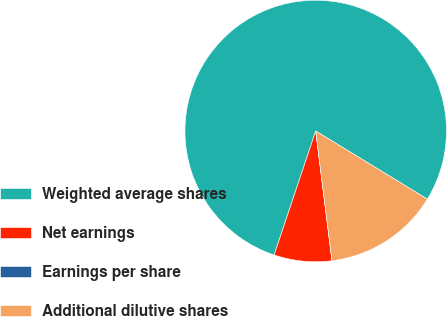<chart> <loc_0><loc_0><loc_500><loc_500><pie_chart><fcel>Weighted average shares<fcel>Net earnings<fcel>Earnings per share<fcel>Additional dilutive shares<nl><fcel>78.57%<fcel>7.14%<fcel>0.0%<fcel>14.29%<nl></chart> 